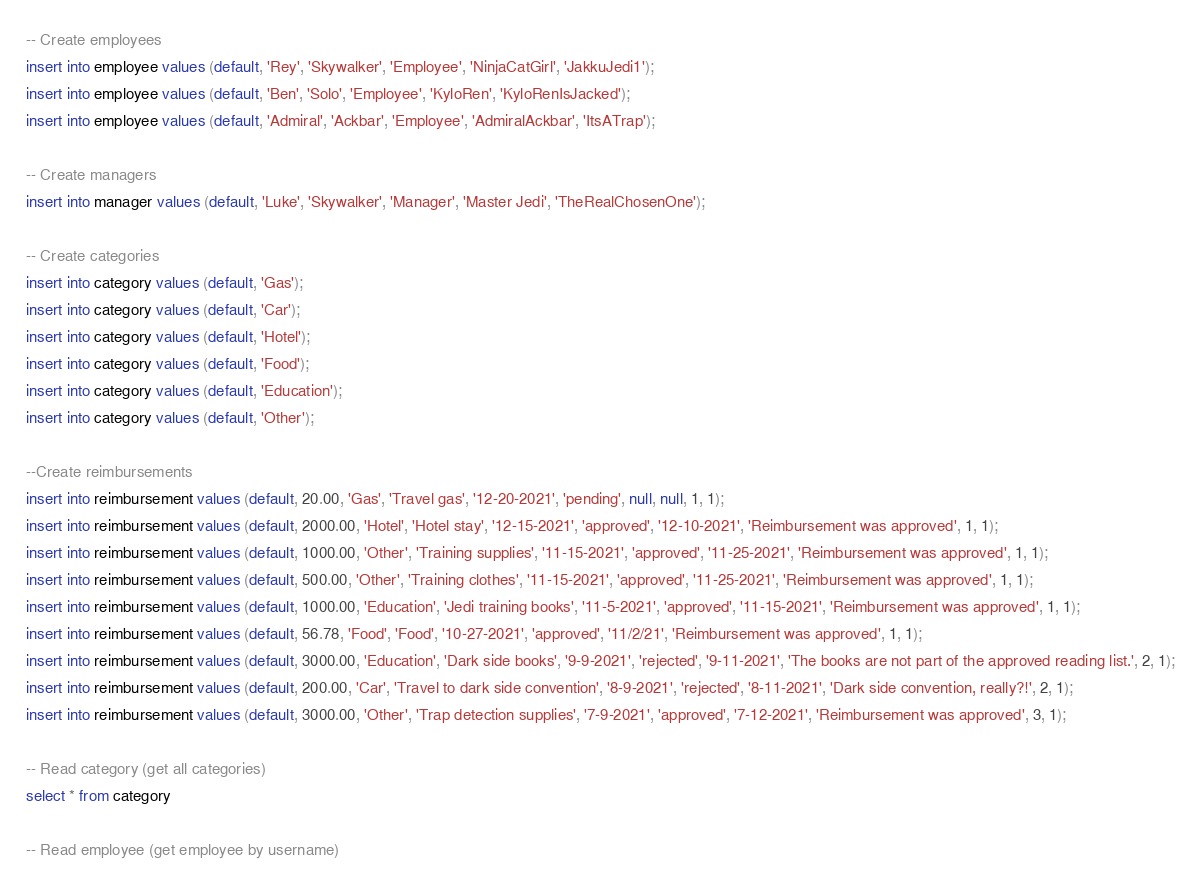<code> <loc_0><loc_0><loc_500><loc_500><_SQL_>-- Create employees
insert into employee values (default, 'Rey', 'Skywalker', 'Employee', 'NinjaCatGirl', 'JakkuJedi1');
insert into employee values (default, 'Ben', 'Solo', 'Employee', 'KyloRen', 'KyloRenIsJacked');
insert into employee values (default, 'Admiral', 'Ackbar', 'Employee', 'AdmiralAckbar', 'ItsATrap');

-- Create managers
insert into manager values (default, 'Luke', 'Skywalker', 'Manager', 'Master Jedi', 'TheRealChosenOne');

-- Create categories
insert into category values (default, 'Gas');
insert into category values (default, 'Car');
insert into category values (default, 'Hotel');
insert into category values (default, 'Food');
insert into category values (default, 'Education');
insert into category values (default, 'Other');

--Create reimbursements
insert into reimbursement values (default, 20.00, 'Gas', 'Travel gas', '12-20-2021', 'pending', null, null, 1, 1);
insert into reimbursement values (default, 2000.00, 'Hotel', 'Hotel stay', '12-15-2021', 'approved', '12-10-2021', 'Reimbursement was approved', 1, 1);
insert into reimbursement values (default, 1000.00, 'Other', 'Training supplies', '11-15-2021', 'approved', '11-25-2021', 'Reimbursement was approved', 1, 1);
insert into reimbursement values (default, 500.00, 'Other', 'Training clothes', '11-15-2021', 'approved', '11-25-2021', 'Reimbursement was approved', 1, 1);
insert into reimbursement values (default, 1000.00, 'Education', 'Jedi training books', '11-5-2021', 'approved', '11-15-2021', 'Reimbursement was approved', 1, 1);
insert into reimbursement values (default, 56.78, 'Food', 'Food', '10-27-2021', 'approved', '11/2/21', 'Reimbursement was approved', 1, 1);
insert into reimbursement values (default, 3000.00, 'Education', 'Dark side books', '9-9-2021', 'rejected', '9-11-2021', 'The books are not part of the approved reading list.', 2, 1);
insert into reimbursement values (default, 200.00, 'Car', 'Travel to dark side convention', '8-9-2021', 'rejected', '8-11-2021', 'Dark side convention, really?!', 2, 1);
insert into reimbursement values (default, 3000.00, 'Other', 'Trap detection supplies', '7-9-2021', 'approved', '7-12-2021', 'Reimbursement was approved', 3, 1);

-- Read category (get all categories)
select * from category

-- Read employee (get employee by username)</code> 